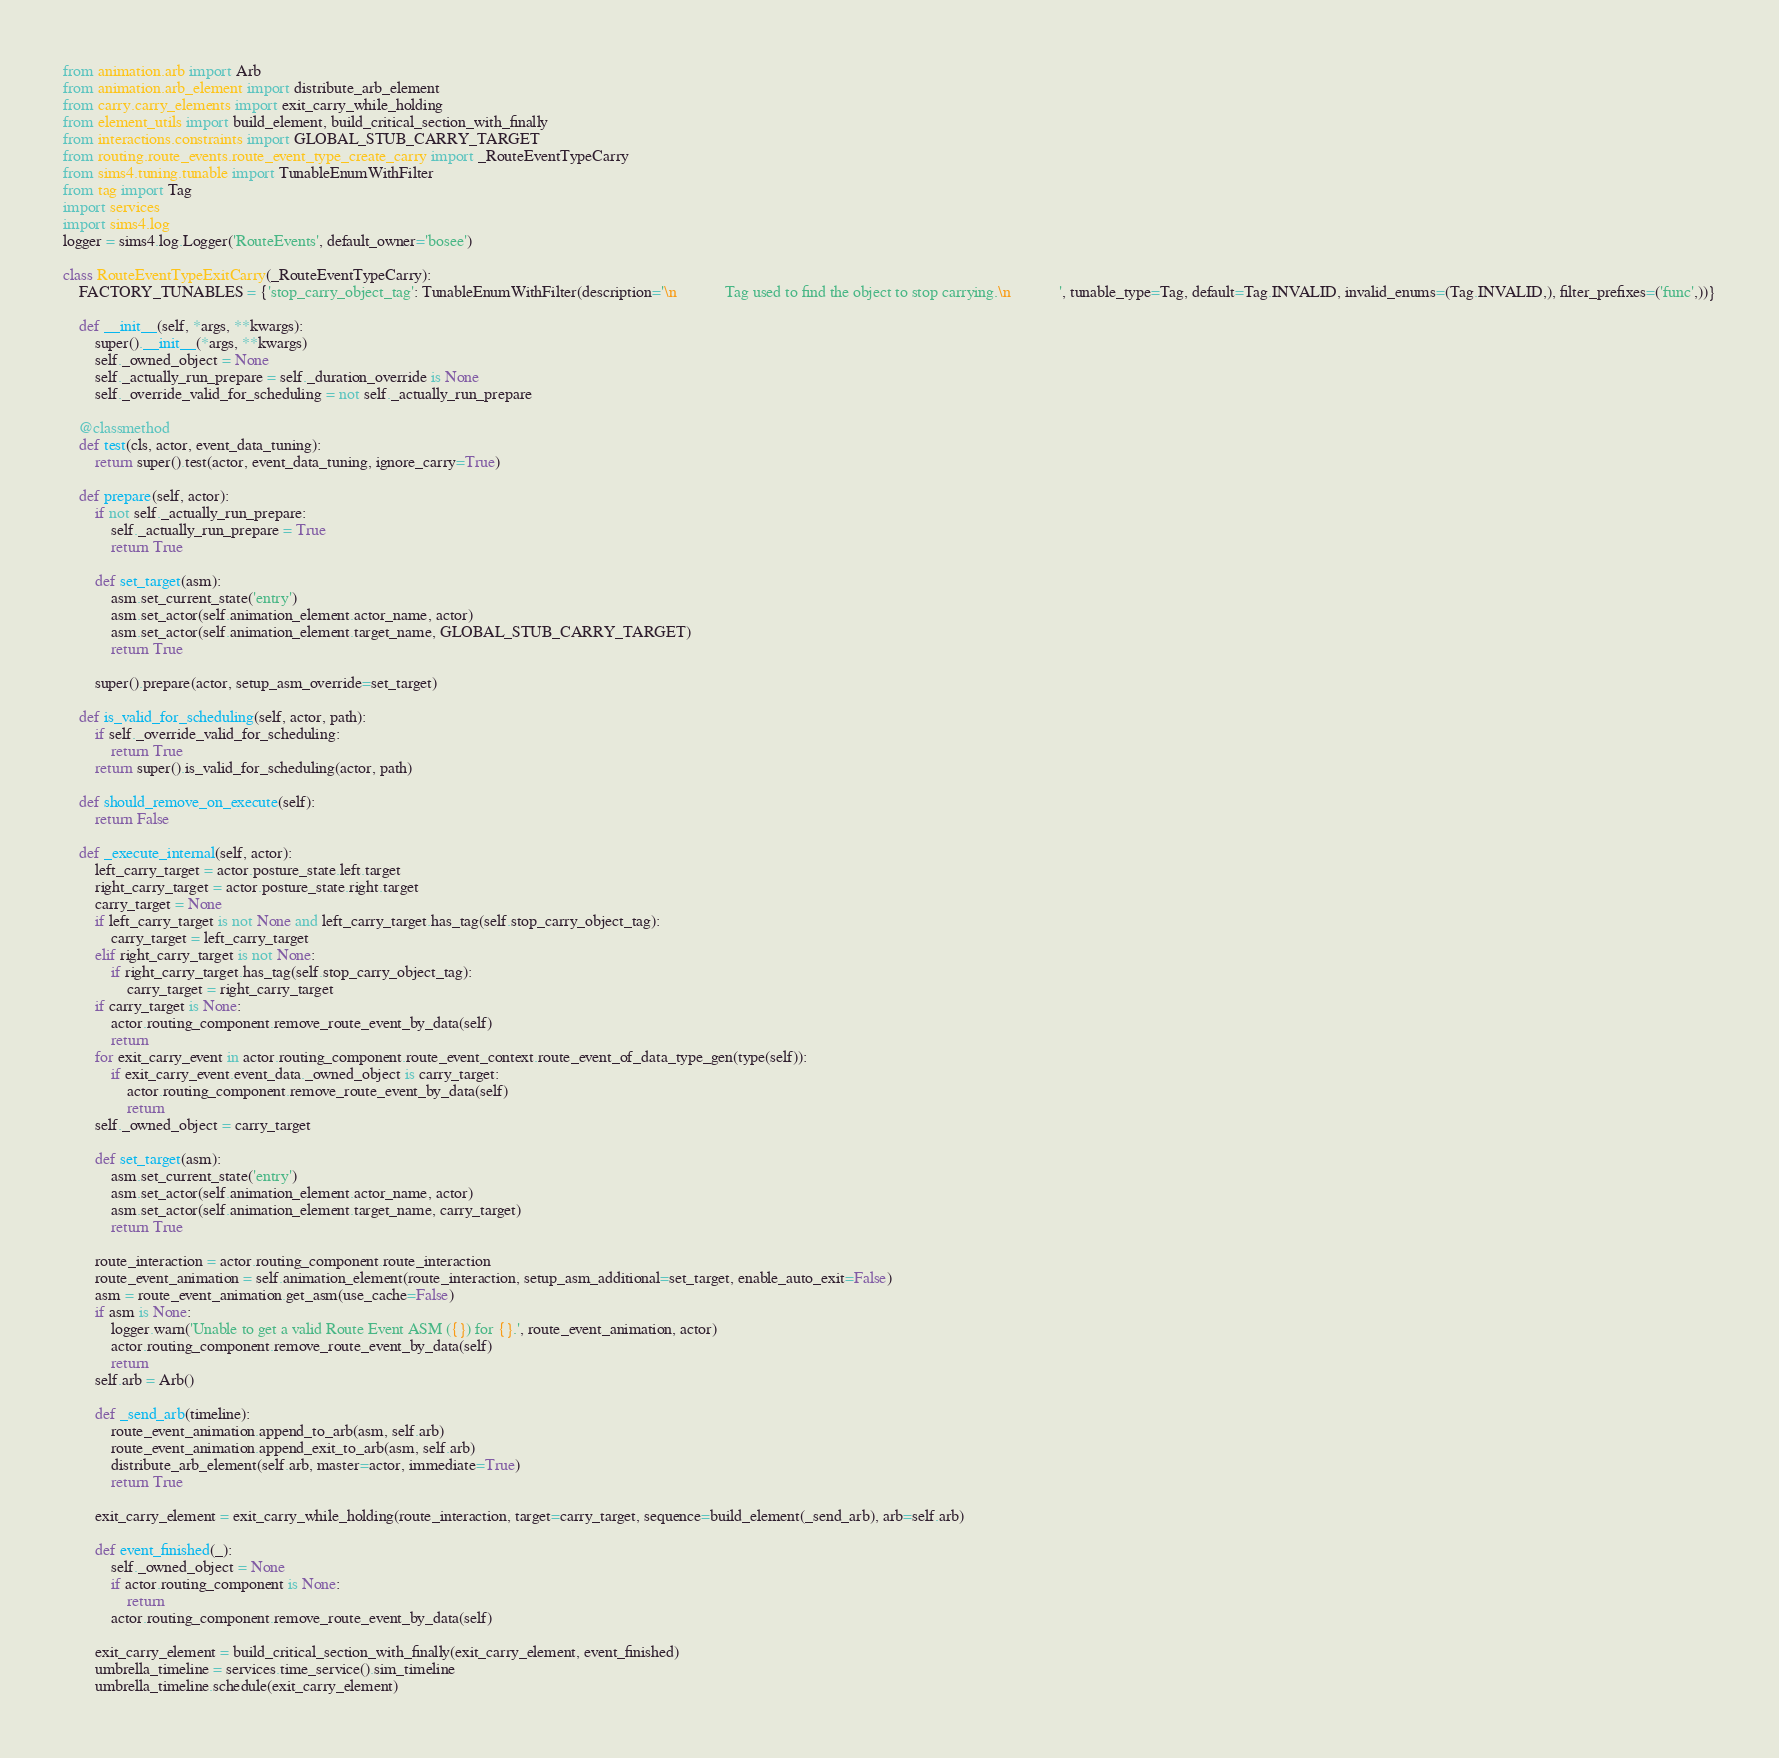<code> <loc_0><loc_0><loc_500><loc_500><_Python_>from animation.arb import Arb
from animation.arb_element import distribute_arb_element
from carry.carry_elements import exit_carry_while_holding
from element_utils import build_element, build_critical_section_with_finally
from interactions.constraints import GLOBAL_STUB_CARRY_TARGET
from routing.route_events.route_event_type_create_carry import _RouteEventTypeCarry
from sims4.tuning.tunable import TunableEnumWithFilter
from tag import Tag
import services
import sims4.log
logger = sims4.log.Logger('RouteEvents', default_owner='bosee')

class RouteEventTypeExitCarry(_RouteEventTypeCarry):
    FACTORY_TUNABLES = {'stop_carry_object_tag': TunableEnumWithFilter(description='\n            Tag used to find the object to stop carrying.\n            ', tunable_type=Tag, default=Tag.INVALID, invalid_enums=(Tag.INVALID,), filter_prefixes=('func',))}

    def __init__(self, *args, **kwargs):
        super().__init__(*args, **kwargs)
        self._owned_object = None
        self._actually_run_prepare = self._duration_override is None
        self._override_valid_for_scheduling = not self._actually_run_prepare

    @classmethod
    def test(cls, actor, event_data_tuning):
        return super().test(actor, event_data_tuning, ignore_carry=True)

    def prepare(self, actor):
        if not self._actually_run_prepare:
            self._actually_run_prepare = True
            return True

        def set_target(asm):
            asm.set_current_state('entry')
            asm.set_actor(self.animation_element.actor_name, actor)
            asm.set_actor(self.animation_element.target_name, GLOBAL_STUB_CARRY_TARGET)
            return True

        super().prepare(actor, setup_asm_override=set_target)

    def is_valid_for_scheduling(self, actor, path):
        if self._override_valid_for_scheduling:
            return True
        return super().is_valid_for_scheduling(actor, path)

    def should_remove_on_execute(self):
        return False

    def _execute_internal(self, actor):
        left_carry_target = actor.posture_state.left.target
        right_carry_target = actor.posture_state.right.target
        carry_target = None
        if left_carry_target is not None and left_carry_target.has_tag(self.stop_carry_object_tag):
            carry_target = left_carry_target
        elif right_carry_target is not None:
            if right_carry_target.has_tag(self.stop_carry_object_tag):
                carry_target = right_carry_target
        if carry_target is None:
            actor.routing_component.remove_route_event_by_data(self)
            return
        for exit_carry_event in actor.routing_component.route_event_context.route_event_of_data_type_gen(type(self)):
            if exit_carry_event.event_data._owned_object is carry_target:
                actor.routing_component.remove_route_event_by_data(self)
                return
        self._owned_object = carry_target

        def set_target(asm):
            asm.set_current_state('entry')
            asm.set_actor(self.animation_element.actor_name, actor)
            asm.set_actor(self.animation_element.target_name, carry_target)
            return True

        route_interaction = actor.routing_component.route_interaction
        route_event_animation = self.animation_element(route_interaction, setup_asm_additional=set_target, enable_auto_exit=False)
        asm = route_event_animation.get_asm(use_cache=False)
        if asm is None:
            logger.warn('Unable to get a valid Route Event ASM ({}) for {}.', route_event_animation, actor)
            actor.routing_component.remove_route_event_by_data(self)
            return
        self.arb = Arb()

        def _send_arb(timeline):
            route_event_animation.append_to_arb(asm, self.arb)
            route_event_animation.append_exit_to_arb(asm, self.arb)
            distribute_arb_element(self.arb, master=actor, immediate=True)
            return True

        exit_carry_element = exit_carry_while_holding(route_interaction, target=carry_target, sequence=build_element(_send_arb), arb=self.arb)

        def event_finished(_):
            self._owned_object = None
            if actor.routing_component is None:
                return
            actor.routing_component.remove_route_event_by_data(self)

        exit_carry_element = build_critical_section_with_finally(exit_carry_element, event_finished)
        umbrella_timeline = services.time_service().sim_timeline
        umbrella_timeline.schedule(exit_carry_element)
</code> 